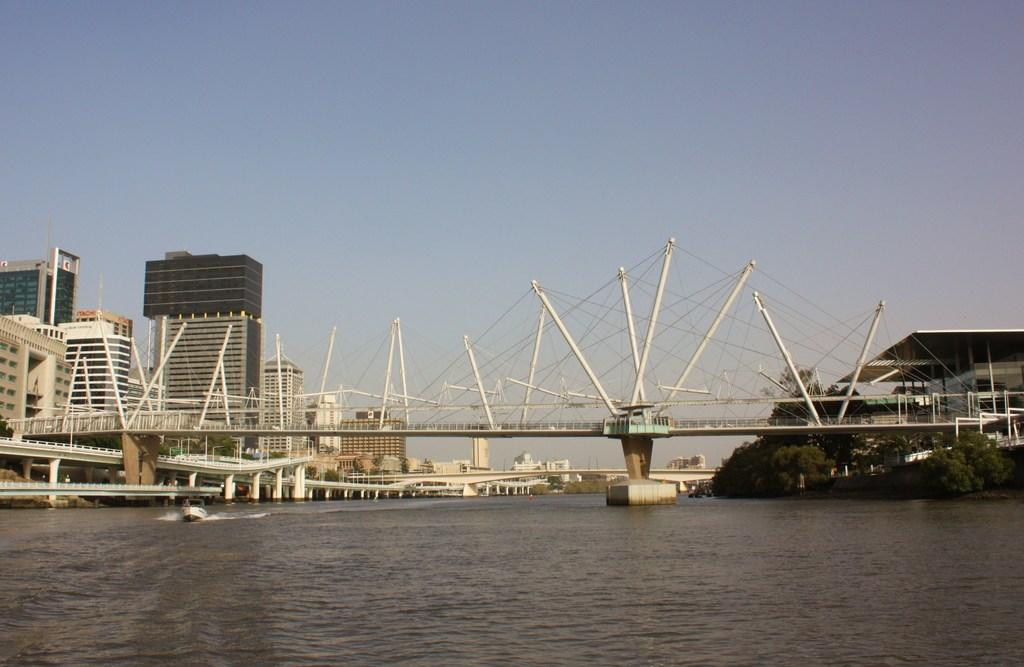What structures can be seen in the image? There are bridges in the image. What is at the bottom of the image? There is water at the bottom of the image. What is floating on the water? There is a boat on the water. What can be seen in the distance in the image? There are buildings and trees in the background of the image. What else is visible in the background of the image? The sky is visible in the background of the image. How many teeth can be seen in the image? There are no teeth visible in the image. What type of wealth is depicted in the image? There is no depiction of wealth in the image; it features bridges, water, a boat, buildings, trees, and the sky. 